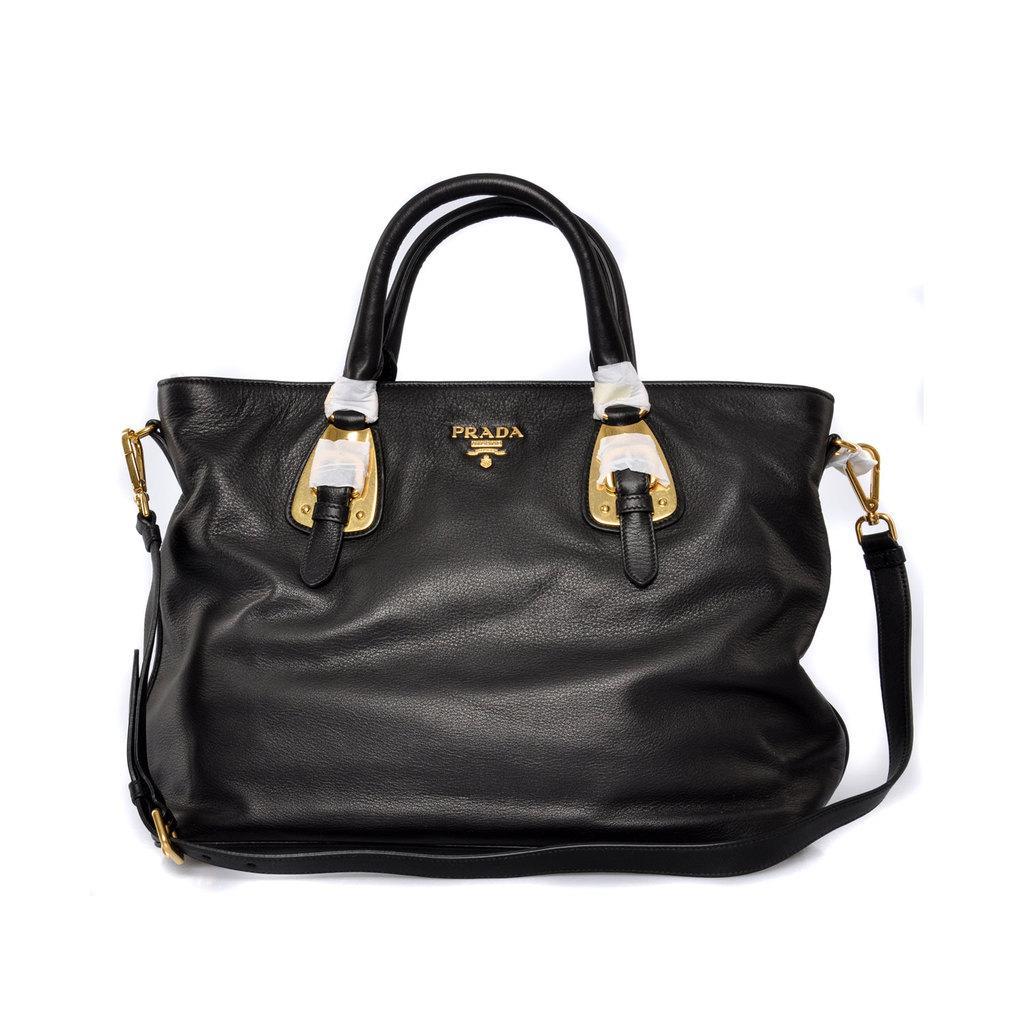Please provide a concise description of this image. There is bag with black color and a strip. 